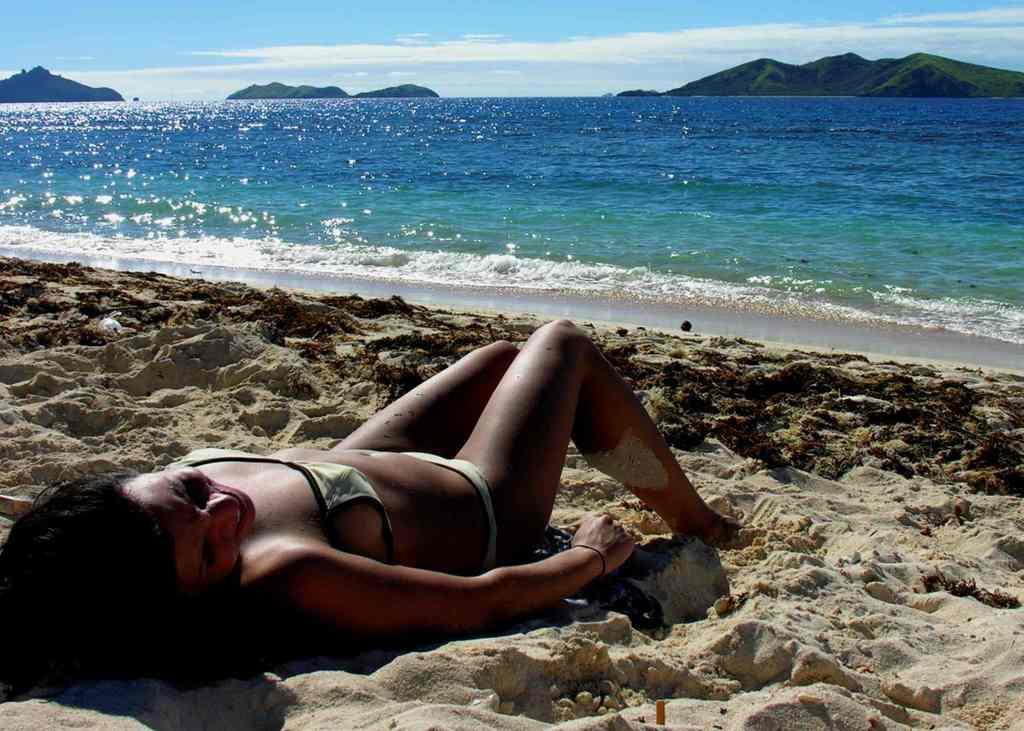Can you describe this image briefly? This image consists of a woman sleeping in the sand near the beach. In the background, there is water along with the mountains. 